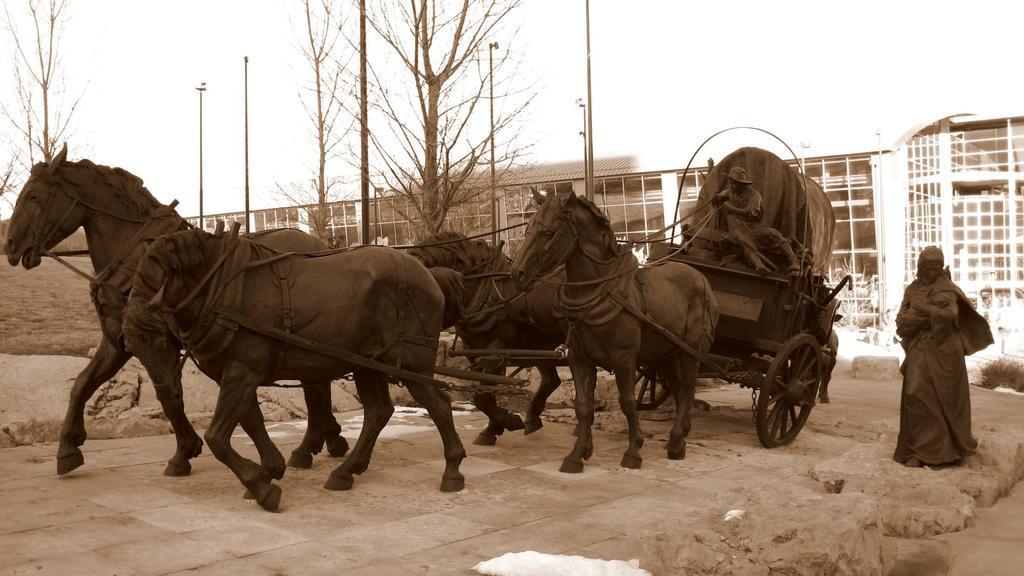How would you summarize this image in a sentence or two? In this image we can see a statue of a horse cart with a person sitting and wearing cap. And he is holding ropes. Near to the cart there is a statue of another person. In the back there is a building. There are trees and poles. In the background there is sky. 